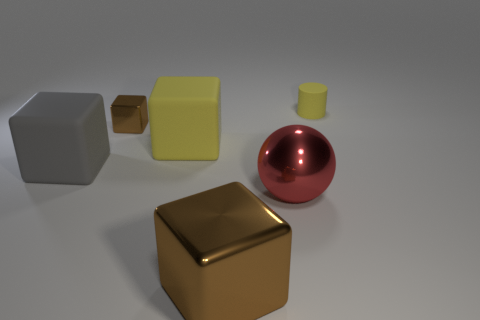There is a small object to the left of the big metal ball; is its color the same as the large metal block?
Keep it short and to the point. Yes. What number of cubes are brown metal objects or large matte objects?
Offer a terse response. 4. There is a block behind the rubber block that is behind the thing that is to the left of the tiny block; what is its size?
Offer a very short reply. Small. There is a metal thing that is the same size as the metal sphere; what shape is it?
Your response must be concise. Cube. The big gray object is what shape?
Your response must be concise. Cube. Are the big brown block in front of the gray object and the big red ball made of the same material?
Keep it short and to the point. Yes. How big is the metal block in front of the matte thing on the left side of the big yellow rubber thing?
Give a very brief answer. Large. What is the color of the metallic object that is in front of the small brown cube and to the left of the big red sphere?
Make the answer very short. Brown. There is a gray block that is the same size as the yellow block; what is its material?
Make the answer very short. Rubber. What number of other objects are the same material as the big sphere?
Offer a very short reply. 2. 